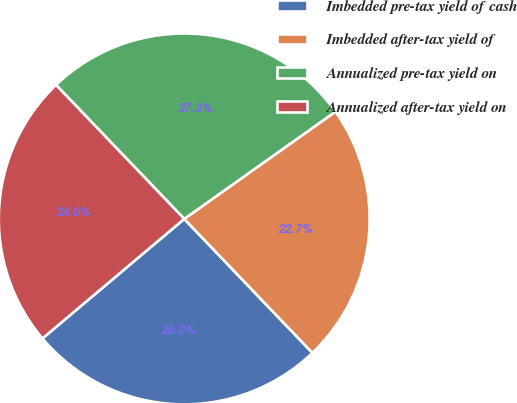Convert chart to OTSL. <chart><loc_0><loc_0><loc_500><loc_500><pie_chart><fcel>Imbedded pre-tax yield of cash<fcel>Imbedded after-tax yield of<fcel>Annualized pre-tax yield on<fcel>Annualized after-tax yield on<nl><fcel>26.0%<fcel>22.67%<fcel>27.33%<fcel>24.0%<nl></chart> 